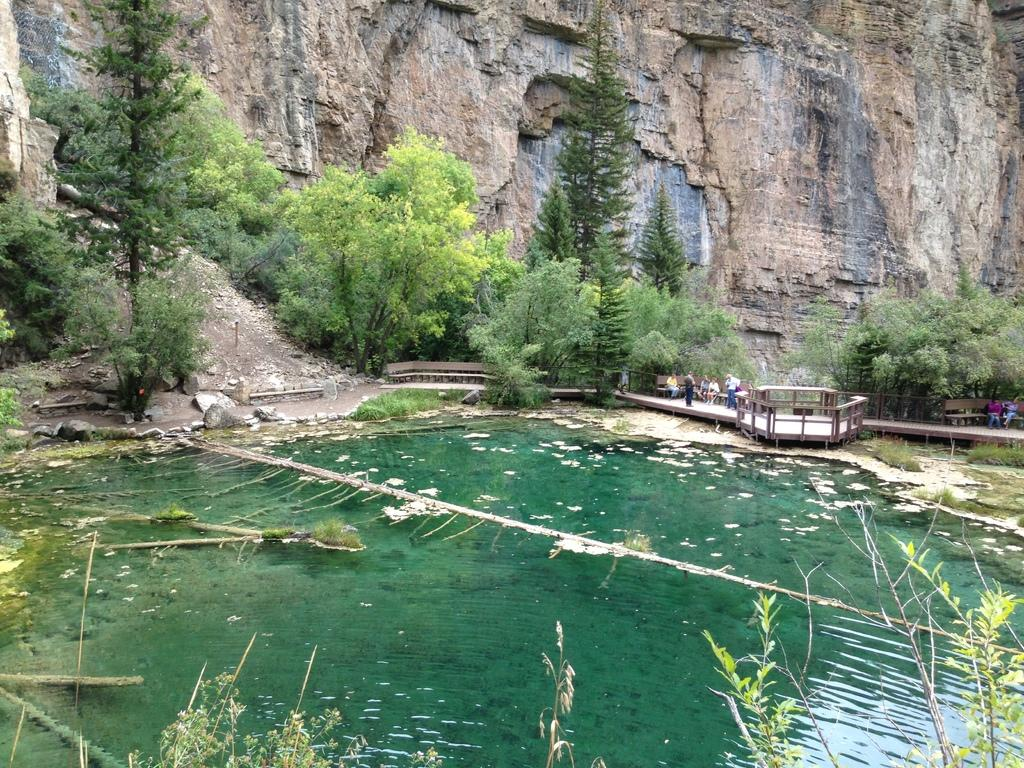What can be seen at the bottom of the image? There are plants and water at the bottom of the image. What type of vegetation is present in the image? There are trees in the image. Who or what is present in the image? There are people in the image. What type of seating is available in the image? There are benches in the image. What type of terrain is visible in the image? There is land visible in the image. What geographical feature is present in the image? There is a hill in the image. Can you tell me how many owls are sitting on the hill in the image? There are no owls present in the image; only plants, water, trees, people, benches, land, and a hill are visible. What type of chicken is being held by the mother in the image? There is no mother or chicken present in the image. 